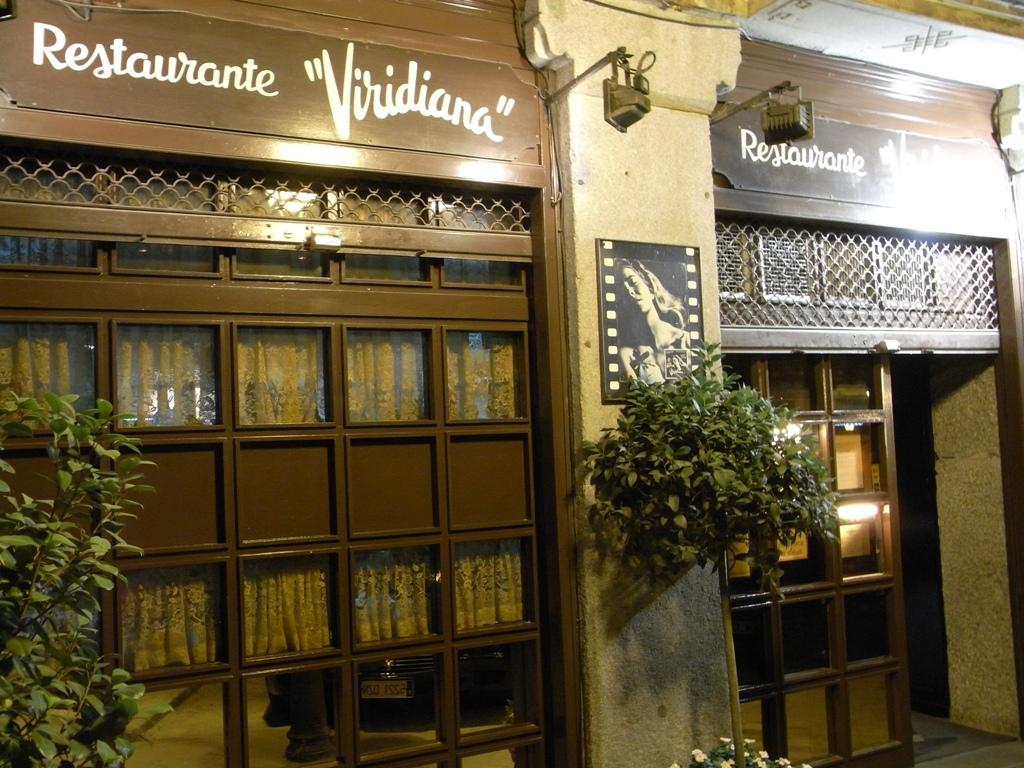Provide a one-sentence caption for the provided image. The exterior of the building Restaurante Viridiana at night. 